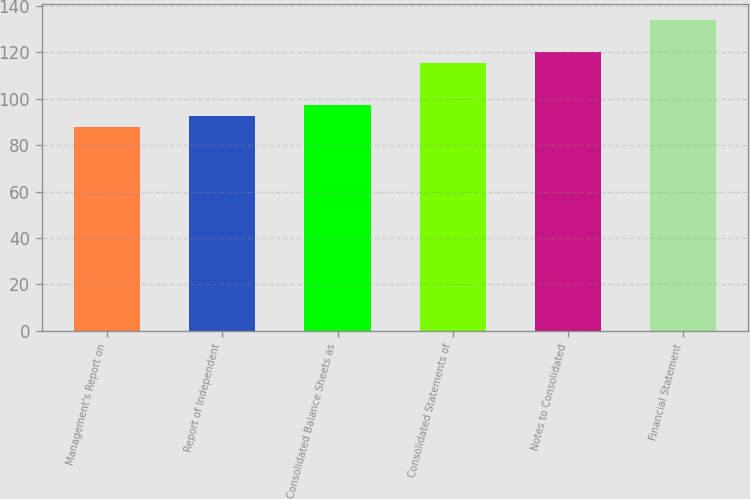<chart> <loc_0><loc_0><loc_500><loc_500><bar_chart><fcel>Management's Report on<fcel>Report of Independent<fcel>Consolidated Balance Sheets as<fcel>Consolidated Statements of<fcel>Notes to Consolidated<fcel>Financial Statement<nl><fcel>88<fcel>92.6<fcel>97.2<fcel>115.6<fcel>120.2<fcel>134<nl></chart> 